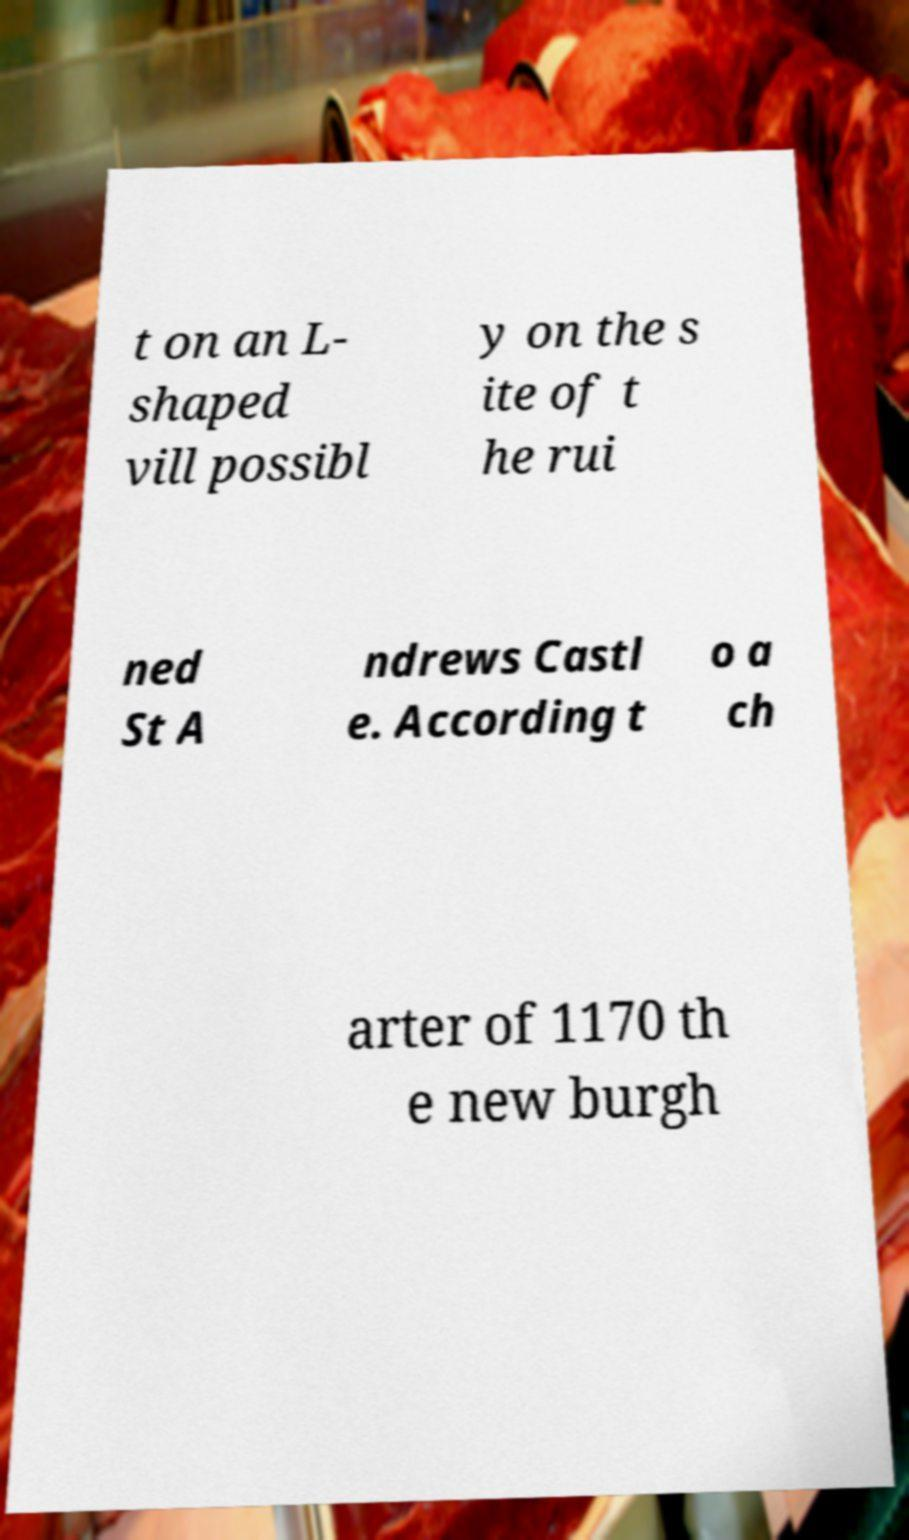Could you assist in decoding the text presented in this image and type it out clearly? t on an L- shaped vill possibl y on the s ite of t he rui ned St A ndrews Castl e. According t o a ch arter of 1170 th e new burgh 